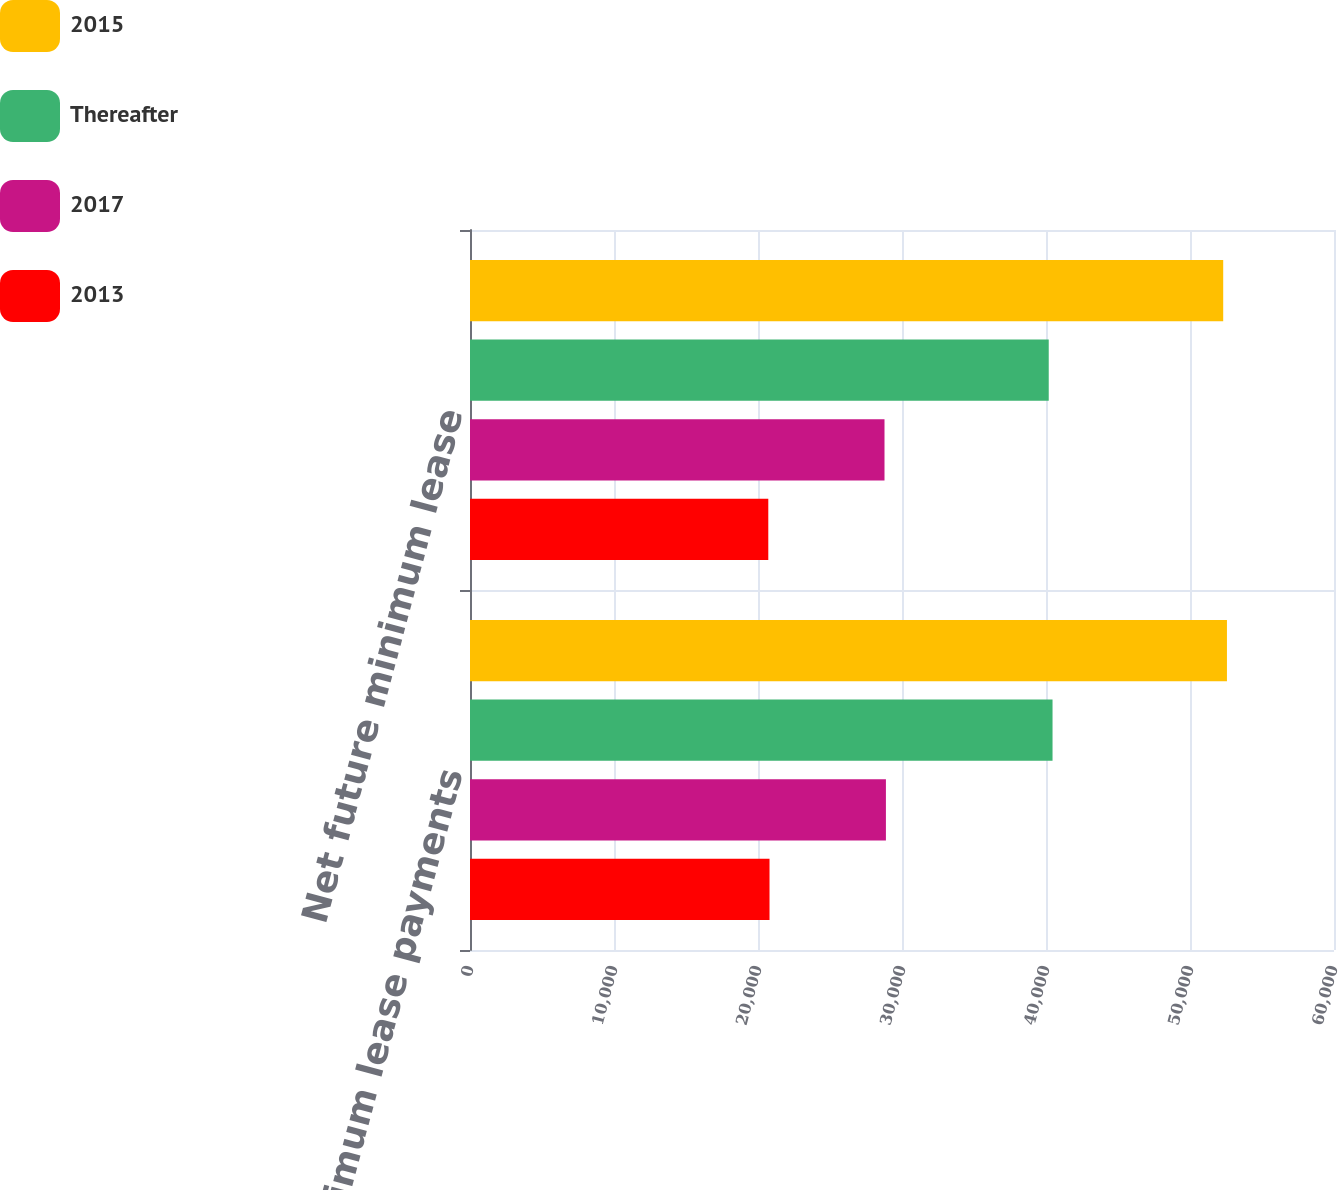Convert chart to OTSL. <chart><loc_0><loc_0><loc_500><loc_500><stacked_bar_chart><ecel><fcel>Minimum lease payments<fcel>Net future minimum lease<nl><fcel>2015<fcel>52566<fcel>52306<nl><fcel>Thereafter<fcel>40454<fcel>40190<nl><fcel>2017<fcel>28883<fcel>28785<nl><fcel>2013<fcel>20800<fcel>20715<nl></chart> 